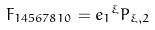<formula> <loc_0><loc_0><loc_500><loc_500>F _ { 1 4 5 6 7 8 1 0 } = { e _ { 1 } } ^ { \xi } P _ { \xi , 2 }</formula> 